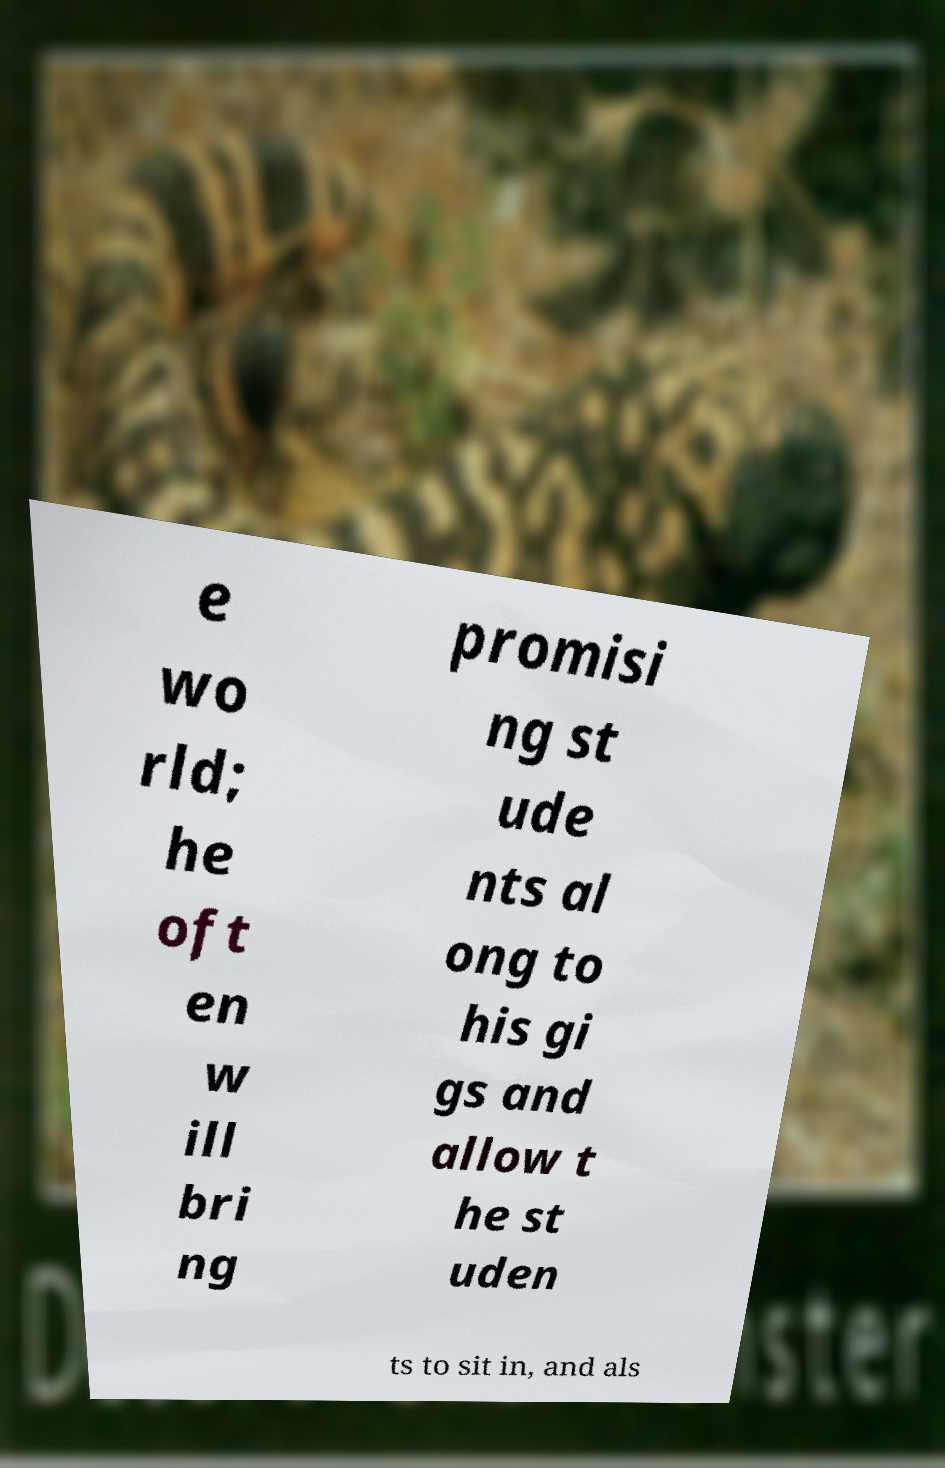There's text embedded in this image that I need extracted. Can you transcribe it verbatim? e wo rld; he oft en w ill bri ng promisi ng st ude nts al ong to his gi gs and allow t he st uden ts to sit in, and als 